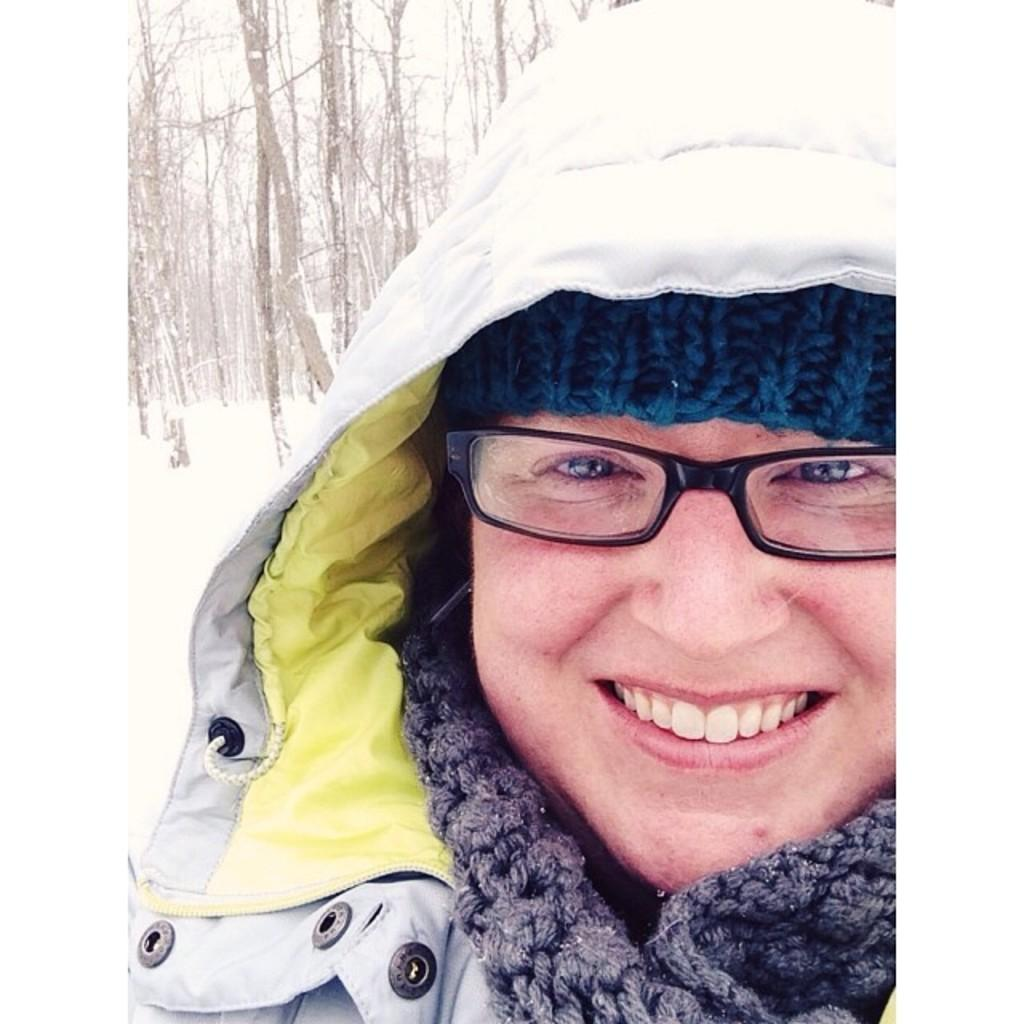Who or what is present in the image? There is a person in the image. What is the person doing in the image? The person is smiling. What can be seen in the background of the image? There is snow and trees in the background of the image. What type of transport is being used by the person in the image? There is no transport visible in the image; it only shows a person smiling in front of a snowy background with trees. 